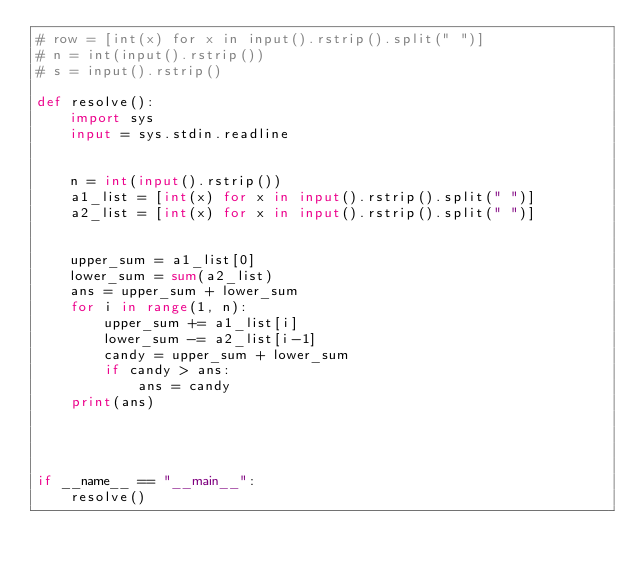Convert code to text. <code><loc_0><loc_0><loc_500><loc_500><_Python_># row = [int(x) for x in input().rstrip().split(" ")]
# n = int(input().rstrip())
# s = input().rstrip()

def resolve():
    import sys
    input = sys.stdin.readline


    n = int(input().rstrip())
    a1_list = [int(x) for x in input().rstrip().split(" ")]
    a2_list = [int(x) for x in input().rstrip().split(" ")]


    upper_sum = a1_list[0]
    lower_sum = sum(a2_list)
    ans = upper_sum + lower_sum
    for i in range(1, n):
        upper_sum += a1_list[i]
        lower_sum -= a2_list[i-1]
        candy = upper_sum + lower_sum
        if candy > ans:
            ans = candy
    print(ans)




if __name__ == "__main__":
    resolve()
</code> 